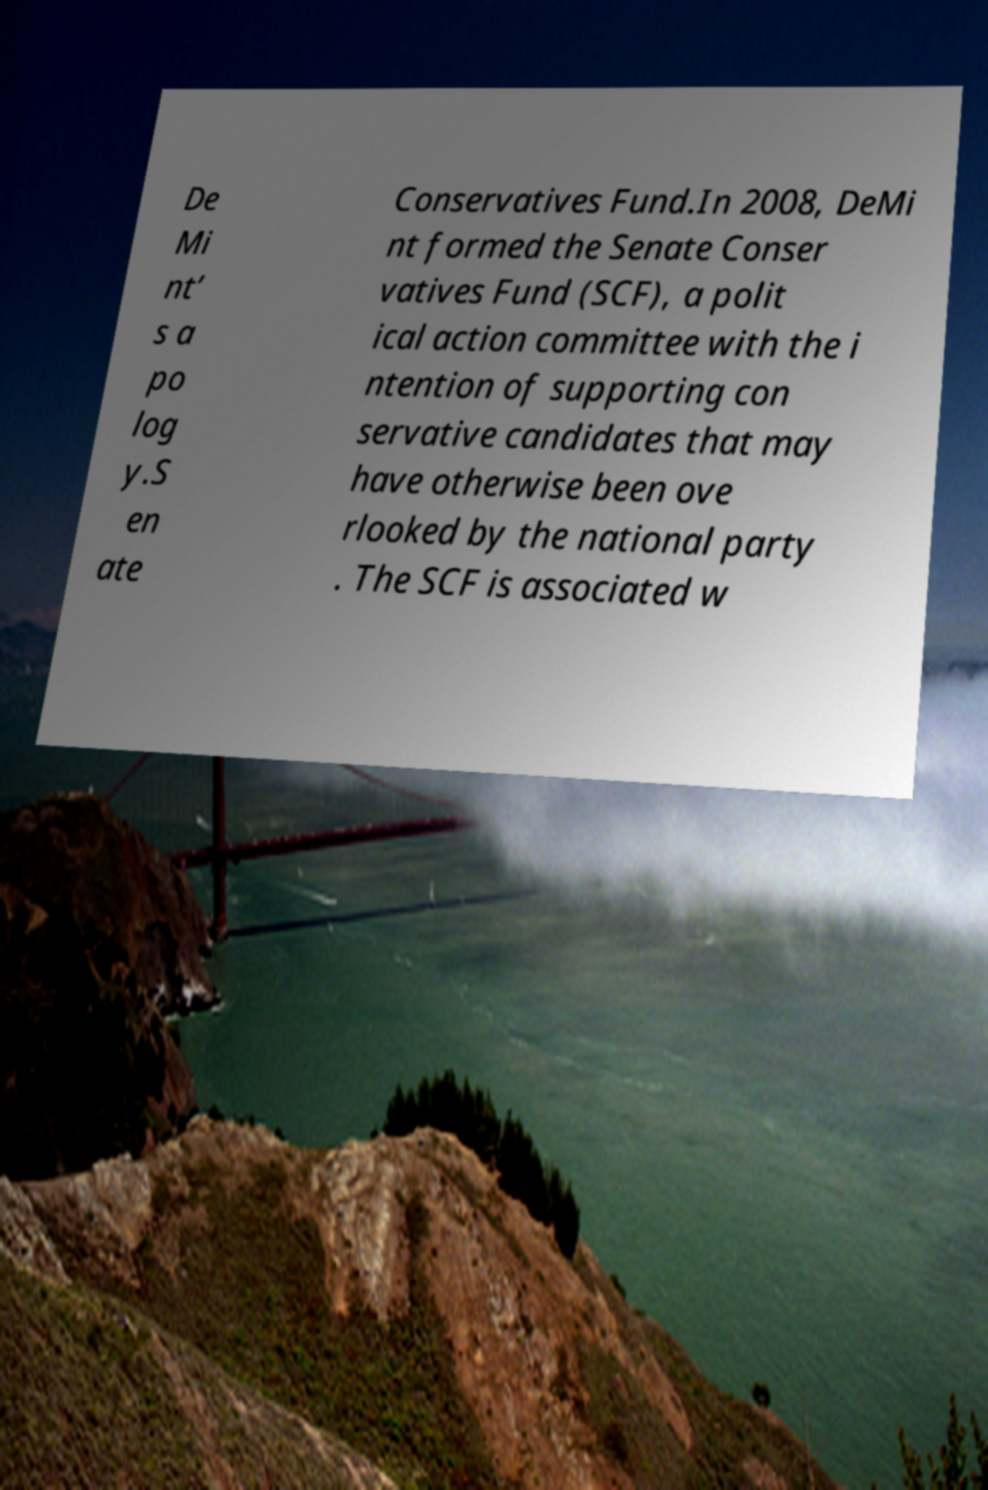Could you assist in decoding the text presented in this image and type it out clearly? De Mi nt’ s a po log y.S en ate Conservatives Fund.In 2008, DeMi nt formed the Senate Conser vatives Fund (SCF), a polit ical action committee with the i ntention of supporting con servative candidates that may have otherwise been ove rlooked by the national party . The SCF is associated w 